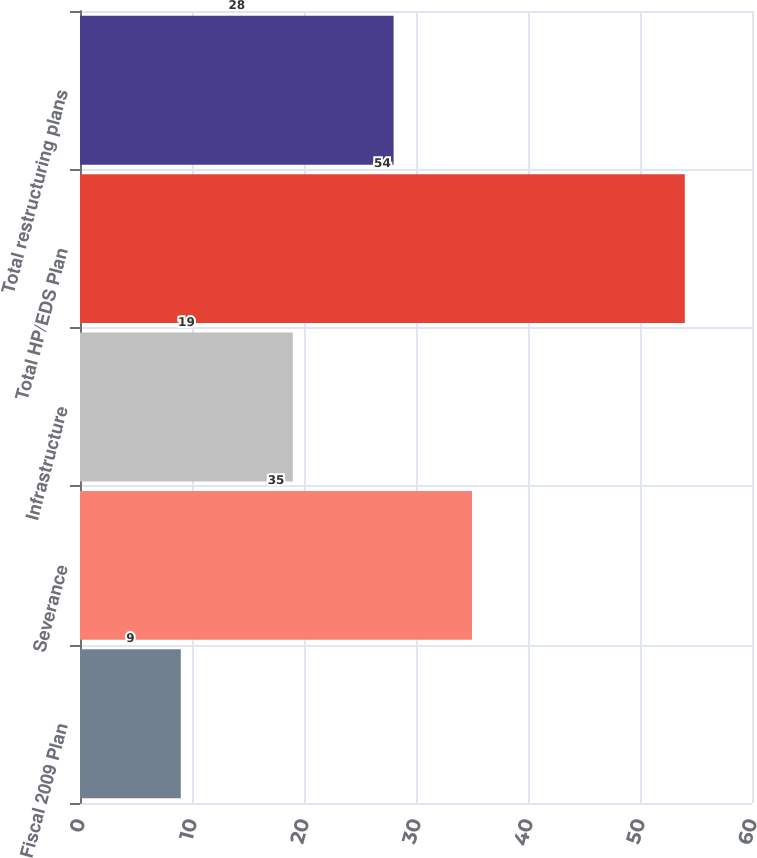Convert chart. <chart><loc_0><loc_0><loc_500><loc_500><bar_chart><fcel>Fiscal 2009 Plan<fcel>Severance<fcel>Infrastructure<fcel>Total HP/EDS Plan<fcel>Total restructuring plans<nl><fcel>9<fcel>35<fcel>19<fcel>54<fcel>28<nl></chart> 